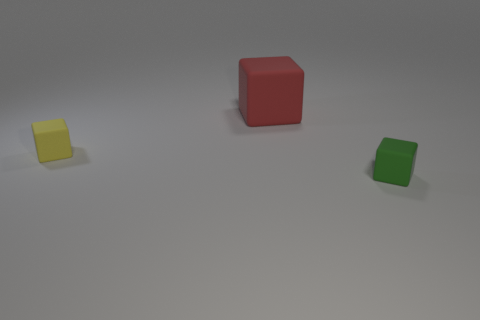Subtract all red blocks. How many blocks are left? 2 Subtract all small blocks. How many blocks are left? 1 Subtract 0 brown spheres. How many objects are left? 3 Subtract 1 blocks. How many blocks are left? 2 Subtract all red blocks. Subtract all green cylinders. How many blocks are left? 2 Subtract all blue cylinders. How many red cubes are left? 1 Subtract all large red cubes. Subtract all tiny rubber objects. How many objects are left? 0 Add 1 red matte things. How many red matte things are left? 2 Add 1 big red cubes. How many big red cubes exist? 2 Add 2 large cyan spheres. How many objects exist? 5 